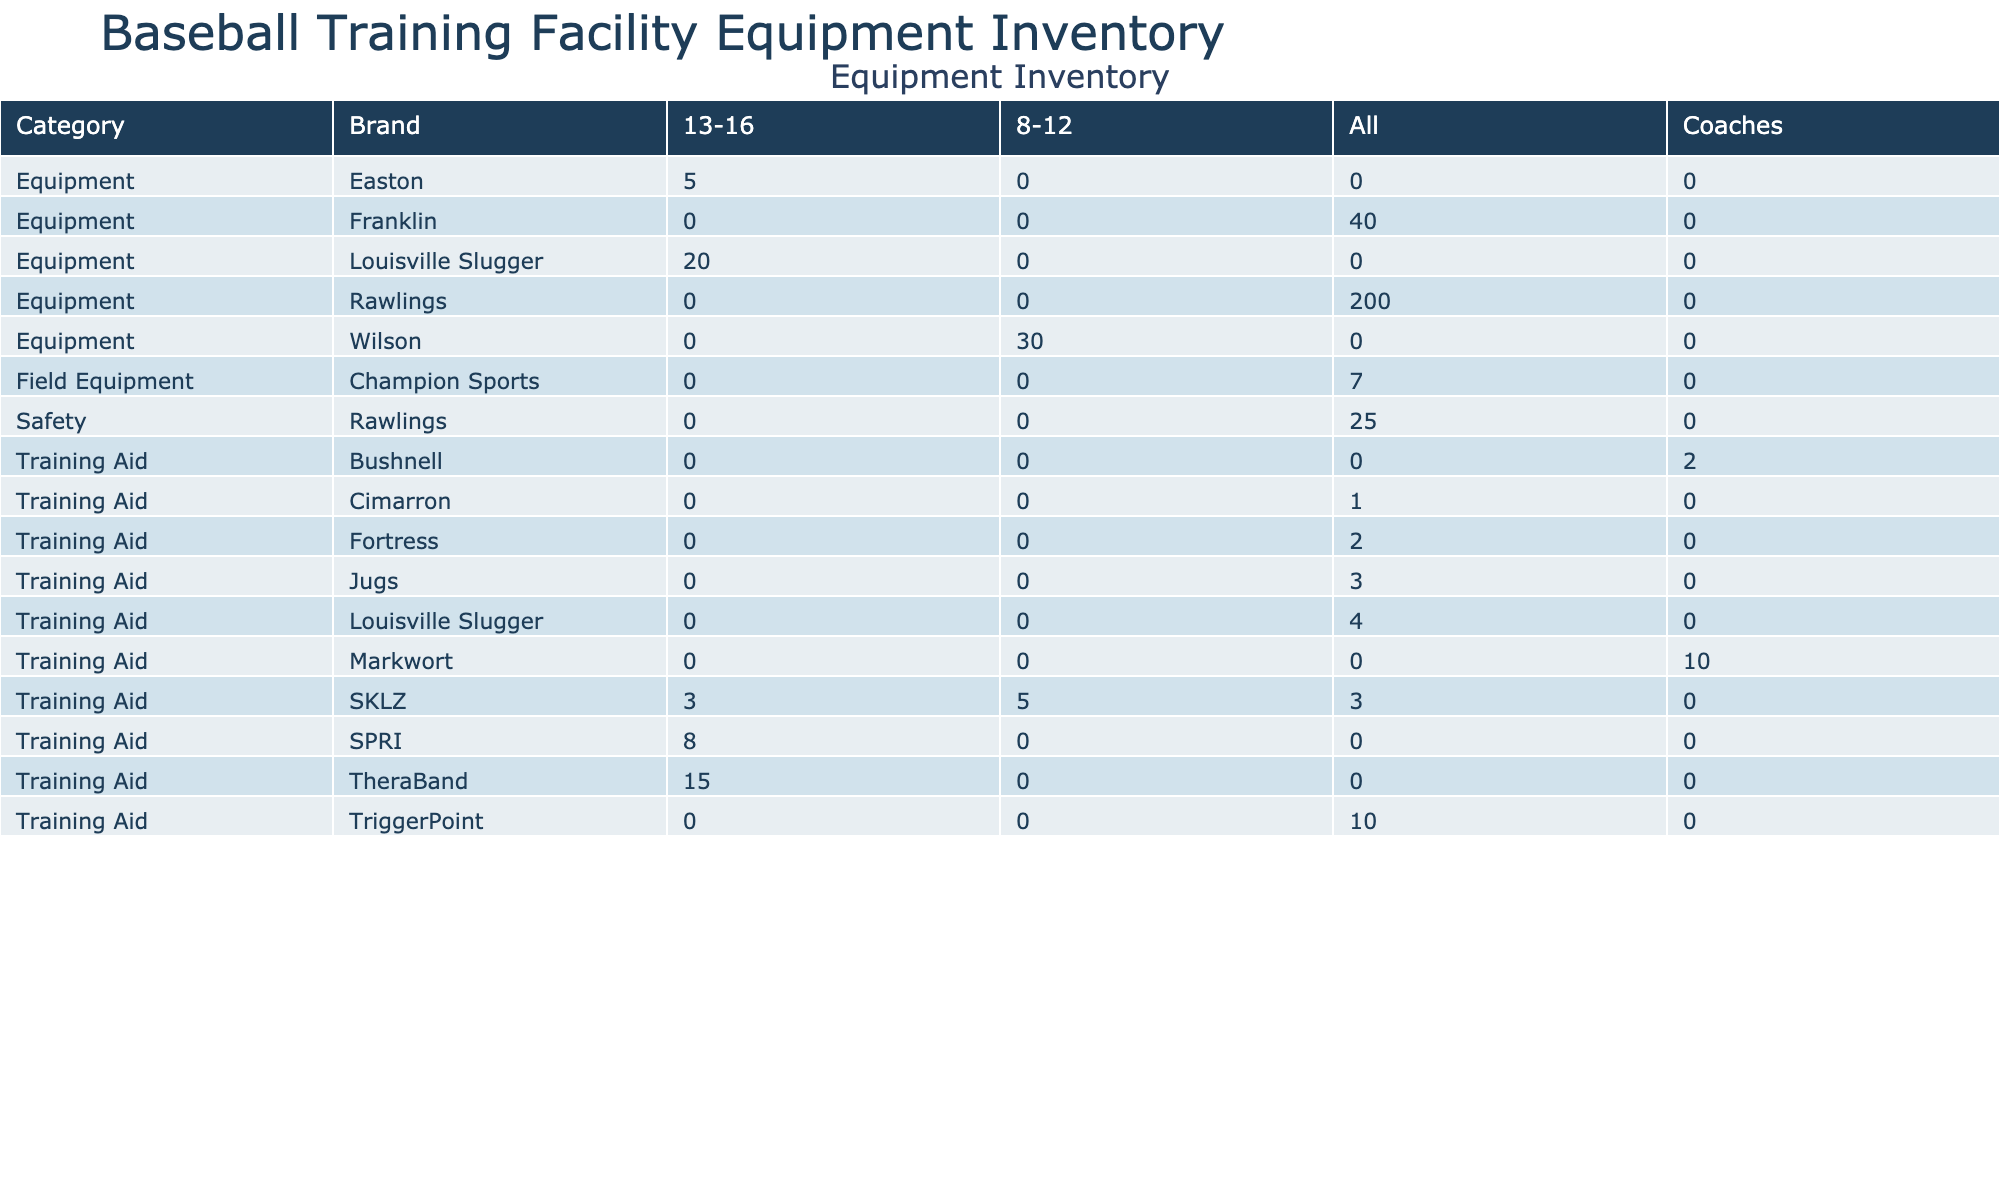What is the total quantity of equipment for the age group 8-12? The total quantity for the age group 8-12 can be found by adding the quantities from all items listed under that age group. The relevant items are the Batting Tee (5), Baseball Glove (30), and Batting Gloves (40). Adding these gives 5 + 30 + 40 = 75.
Answer: 75 What is the average quantity of safety equipment? The only safety equipment listed is the Batting Helmet, with a quantity of 25. Since there is only one item, the average is simply 25.
Answer: 25 Is there any equipment that is labeled in 'Excellent' condition? By examining the condition column, we can find that there are items in 'Excellent' condition: Batting Cage Net, Pitching Rubber, Pitching Target, Foam Roller, Agility Ladder, and Batting Cage. Therefore, the answer is yes.
Answer: Yes Which brand has the highest quantity of equipment available? To find this, we compare the total quantities for each brand. The totals are Louisville Slugger (20), Wilson (30), Rawlings (200), Easton (5), SKLZ (5+3+15+3 = 26), TheraBand (15), Jugs (3), and others. The highest total is 200 for Rawlings.
Answer: Rawlings How many training aids are available for all age groups? All training aid items should be checked for their quantities. The counted items are Batting Tee (5), Batting Cage Net (2), Pitching Machine (3), Pitch Counter (10), Radar Gun (2), Agility Ladder (3), Resistance Bands (15), Medicine Ball (8), Foam Roller (10), Weighted Baseball Set (3), and Batting Cage (1). Summing these gives 5 + 2 + 3 + 10 + 2 + 3 + 15 + 8 + 10 + 3 + 1 = 62.
Answer: 62 What is the combined total quantity of equipment categorized under 'Field Equipment'? For 'Field Equipment,' we check the items listed: Pitching Rubber (4) and Home Plate (3). The combined total is 4 + 3 = 7.
Answer: 7 Is there a brand of baseball gear that has a usage frequency of 'Monthly'? Looking at the usage frequency, both items under Field Equipment (Pitching Rubber and Home Plate) have a frequency of 'Monthly.' Since both items belong to the Champion Sports brand, we conclude that the answer is yes.
Answer: Yes How many pieces of equipment are categorized as 'Equipment' and have a quantity greater than 20? The items in the 'Equipment' category and their respective quantities include Baseball Bat (20), Baseball Glove (30), and Baseball (200). The quantities greater than 20 are Baseball Glove (30) and Baseball (200). Therefore, there are two items fulfilling this condition.
Answer: 2 What is the difference in quantity between the most and least used training aids? The most used training aid is the Resistance Bands with a quantity of 15, while the least used is the Agility Ladder and Weighted Baseball set, both with quantities of 3. The difference between the highest (15) and the lowest (3) is 15 - 3 = 12.
Answer: 12 Which age group has the most diverse range of equipment? To determine this, we consider the mentioned age groups for each category. The age group 'All' has multiple items like Batting Cage Net, Batting Helmet, Baseball, Pitching Machine, etc., compared to the specific age groups of 8-12 and 13-16. Therefore, 'All' shows the most diverse range of equipment.
Answer: All 